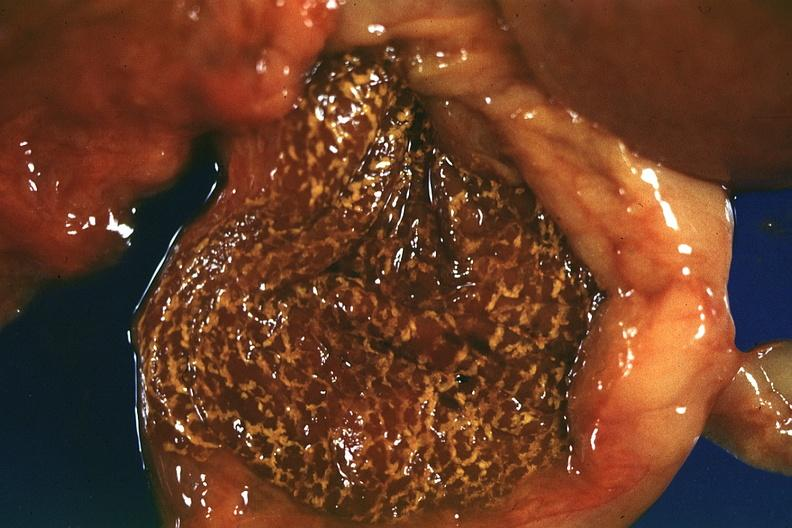s this typical thecoma with yellow foci present?
Answer the question using a single word or phrase. No 